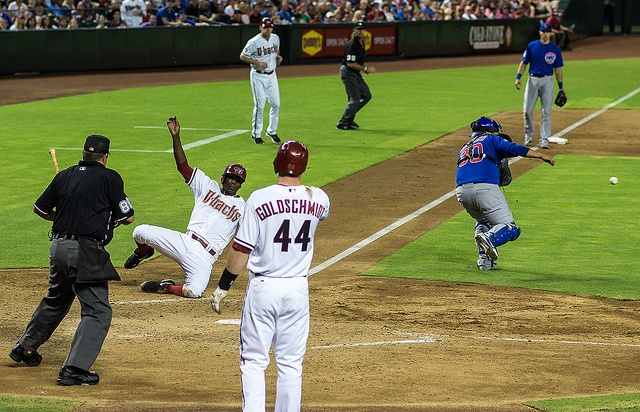Describe the objects in this image and their specific colors. I can see people in black, lavender, and darkgray tones, people in black, gray, and purple tones, people in black, lightgray, olive, and maroon tones, people in black, darkgray, darkblue, and navy tones, and people in black, navy, gray, and darkgray tones in this image. 